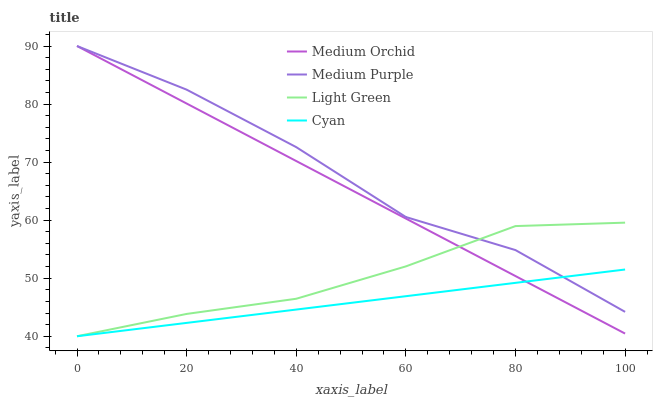Does Cyan have the minimum area under the curve?
Answer yes or no. Yes. Does Medium Purple have the maximum area under the curve?
Answer yes or no. Yes. Does Medium Orchid have the minimum area under the curve?
Answer yes or no. No. Does Medium Orchid have the maximum area under the curve?
Answer yes or no. No. Is Cyan the smoothest?
Answer yes or no. Yes. Is Medium Purple the roughest?
Answer yes or no. Yes. Is Medium Orchid the smoothest?
Answer yes or no. No. Is Medium Orchid the roughest?
Answer yes or no. No. Does Cyan have the lowest value?
Answer yes or no. Yes. Does Medium Orchid have the lowest value?
Answer yes or no. No. Does Medium Orchid have the highest value?
Answer yes or no. Yes. Does Cyan have the highest value?
Answer yes or no. No. Does Medium Orchid intersect Medium Purple?
Answer yes or no. Yes. Is Medium Orchid less than Medium Purple?
Answer yes or no. No. Is Medium Orchid greater than Medium Purple?
Answer yes or no. No. 